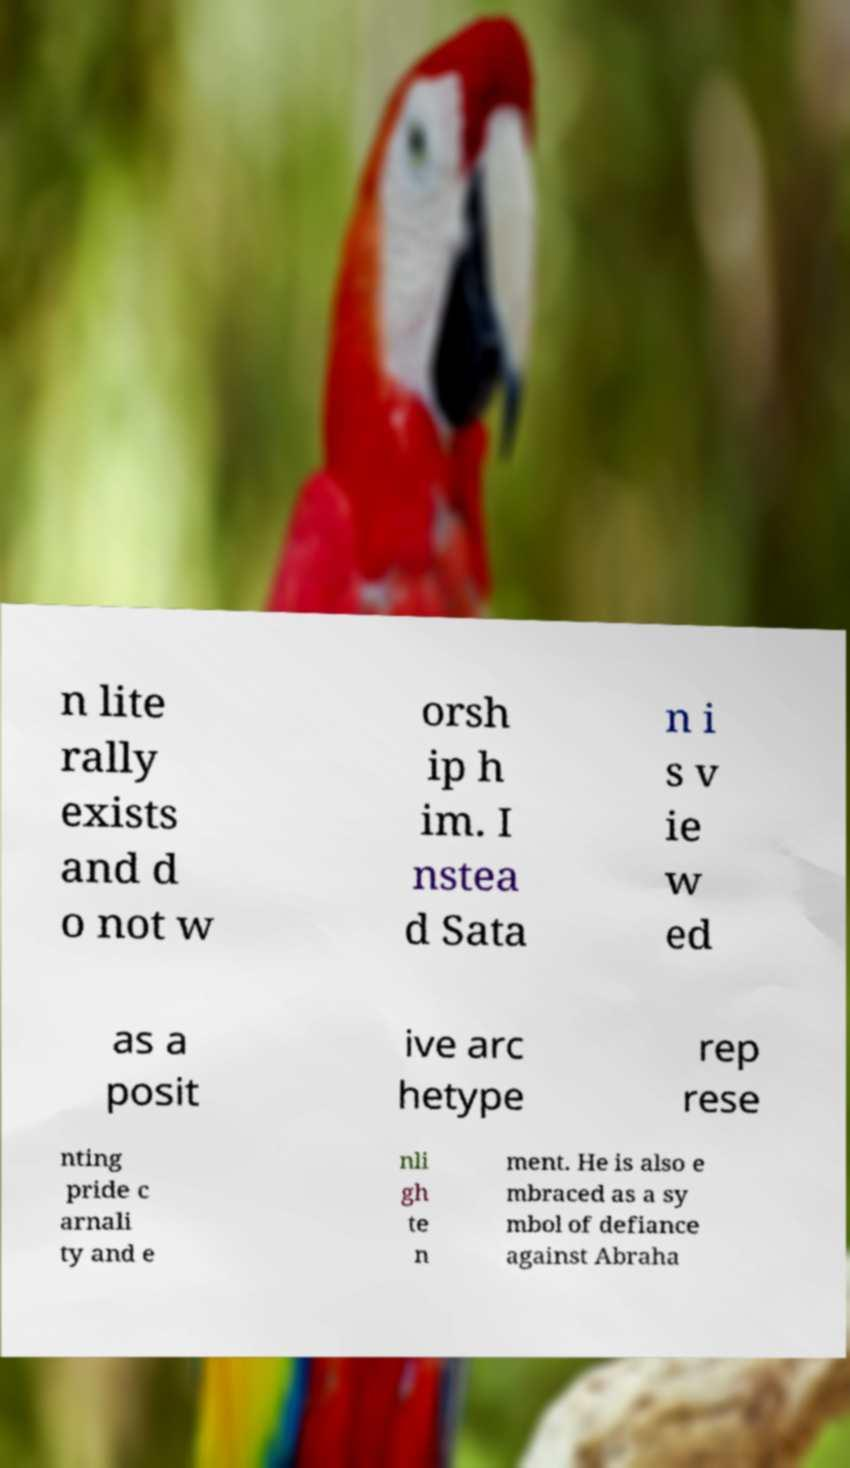Can you read and provide the text displayed in the image?This photo seems to have some interesting text. Can you extract and type it out for me? n lite rally exists and d o not w orsh ip h im. I nstea d Sata n i s v ie w ed as a posit ive arc hetype rep rese nting pride c arnali ty and e nli gh te n ment. He is also e mbraced as a sy mbol of defiance against Abraha 